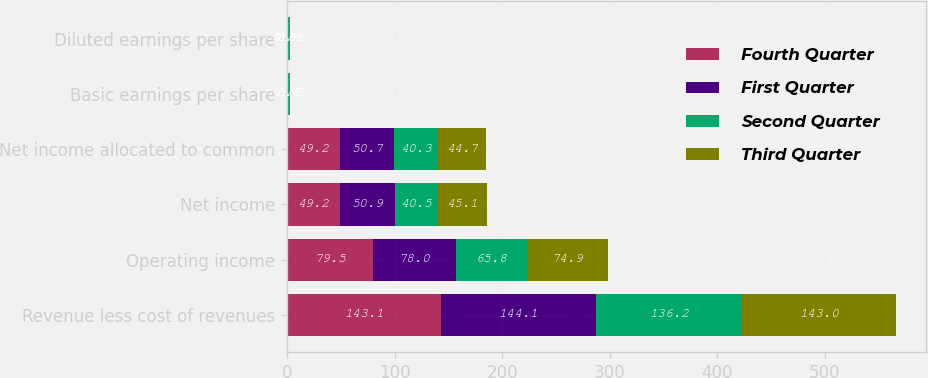Convert chart. <chart><loc_0><loc_0><loc_500><loc_500><stacked_bar_chart><ecel><fcel>Revenue less cost of revenues<fcel>Operating income<fcel>Net income<fcel>Net income allocated to common<fcel>Basic earnings per share<fcel>Diluted earnings per share<nl><fcel>Fourth Quarter<fcel>143.1<fcel>79.5<fcel>49.2<fcel>49.2<fcel>0.6<fcel>0.6<nl><fcel>First Quarter<fcel>144.1<fcel>78<fcel>50.9<fcel>50.7<fcel>0.62<fcel>0.62<nl><fcel>Second Quarter<fcel>136.2<fcel>65.8<fcel>40.5<fcel>40.3<fcel>0.5<fcel>0.5<nl><fcel>Third Quarter<fcel>143<fcel>74.9<fcel>45.1<fcel>44.7<fcel>0.55<fcel>0.55<nl></chart> 